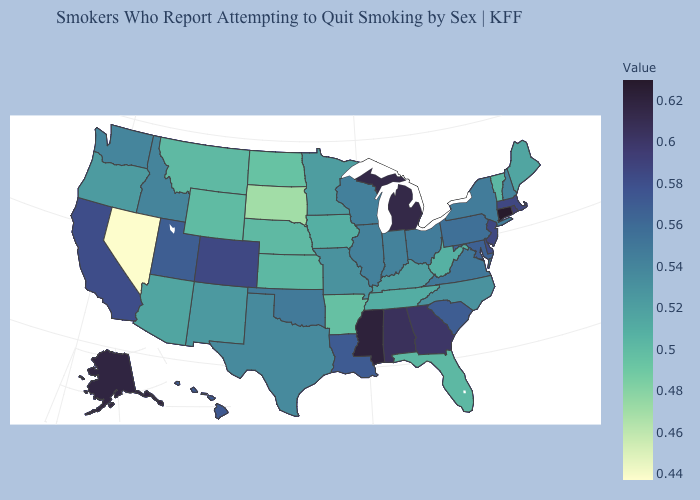Among the states that border Arkansas , does Mississippi have the highest value?
Be succinct. Yes. Which states have the lowest value in the MidWest?
Write a very short answer. South Dakota. 